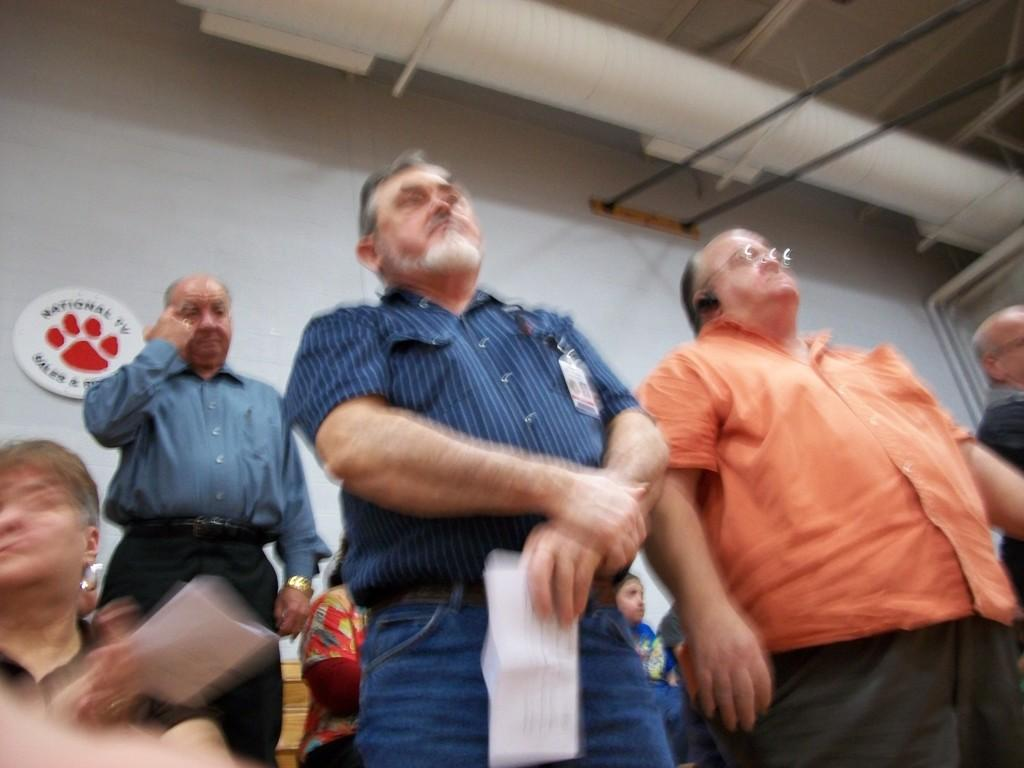How many people are in the image? There is a group of people in the image. What are the people doing in the image? The people are standing. What is behind the people in the image? There is a wall behind the people. What can be seen at the top of the image? There are items visible at the top of the image. What type of force is being exerted by the people in the image? There is no indication of any force being exerted by the people in the image; they are simply standing. 